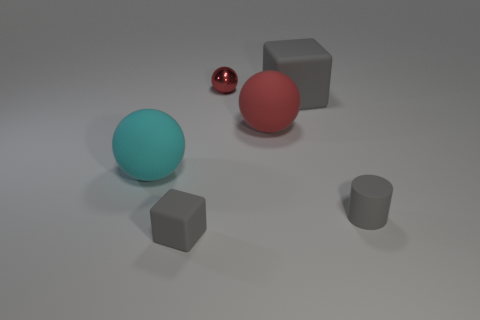Add 4 metal balls. How many objects exist? 10 Subtract all cubes. How many objects are left? 4 Add 4 tiny matte things. How many tiny matte things exist? 6 Subtract 0 green cylinders. How many objects are left? 6 Subtract all cyan rubber cylinders. Subtract all small gray things. How many objects are left? 4 Add 2 small gray objects. How many small gray objects are left? 4 